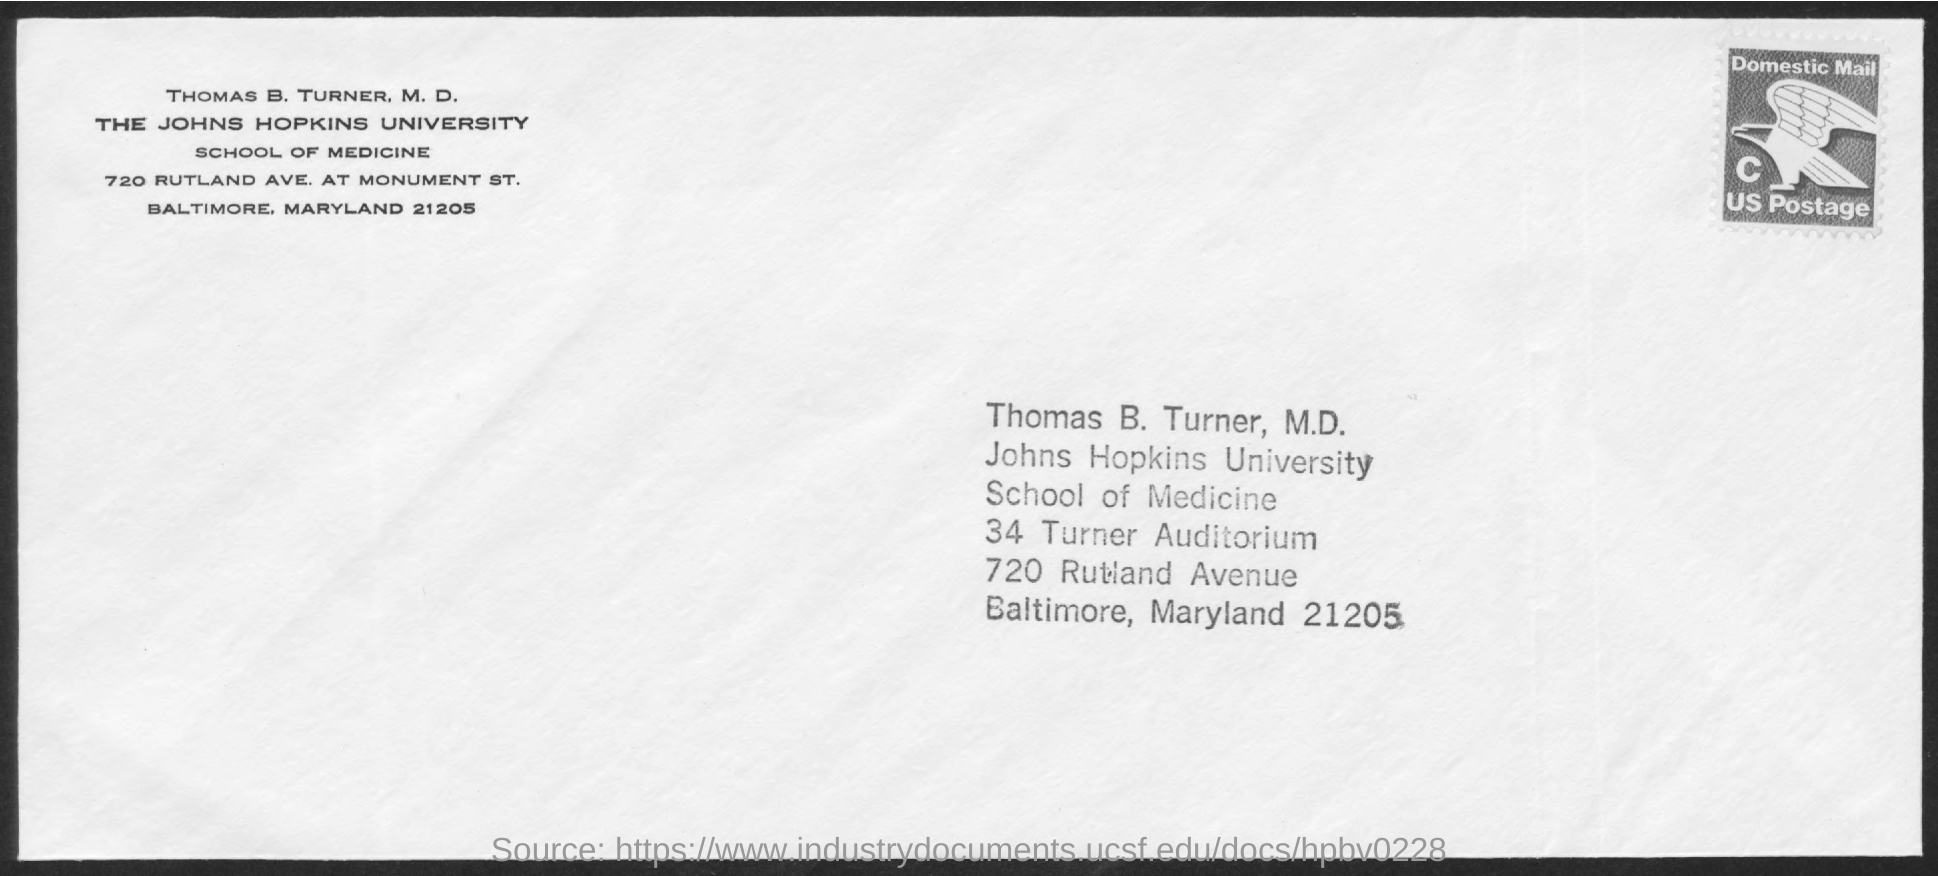To Whom is this letter addressed to?
Your response must be concise. Thomas B. Turner, M.D. 